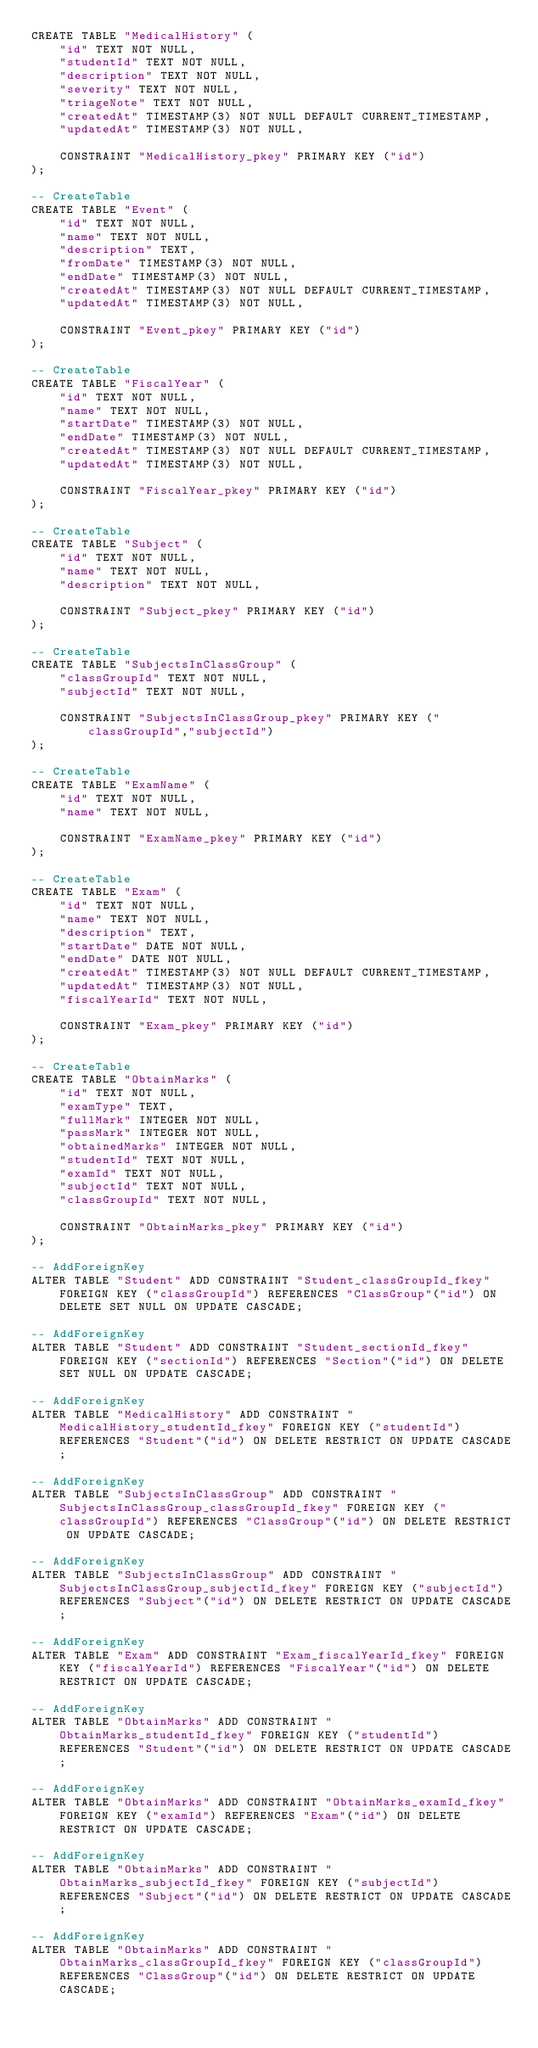Convert code to text. <code><loc_0><loc_0><loc_500><loc_500><_SQL_>CREATE TABLE "MedicalHistory" (
    "id" TEXT NOT NULL,
    "studentId" TEXT NOT NULL,
    "description" TEXT NOT NULL,
    "severity" TEXT NOT NULL,
    "triageNote" TEXT NOT NULL,
    "createdAt" TIMESTAMP(3) NOT NULL DEFAULT CURRENT_TIMESTAMP,
    "updatedAt" TIMESTAMP(3) NOT NULL,

    CONSTRAINT "MedicalHistory_pkey" PRIMARY KEY ("id")
);

-- CreateTable
CREATE TABLE "Event" (
    "id" TEXT NOT NULL,
    "name" TEXT NOT NULL,
    "description" TEXT,
    "fromDate" TIMESTAMP(3) NOT NULL,
    "endDate" TIMESTAMP(3) NOT NULL,
    "createdAt" TIMESTAMP(3) NOT NULL DEFAULT CURRENT_TIMESTAMP,
    "updatedAt" TIMESTAMP(3) NOT NULL,

    CONSTRAINT "Event_pkey" PRIMARY KEY ("id")
);

-- CreateTable
CREATE TABLE "FiscalYear" (
    "id" TEXT NOT NULL,
    "name" TEXT NOT NULL,
    "startDate" TIMESTAMP(3) NOT NULL,
    "endDate" TIMESTAMP(3) NOT NULL,
    "createdAt" TIMESTAMP(3) NOT NULL DEFAULT CURRENT_TIMESTAMP,
    "updatedAt" TIMESTAMP(3) NOT NULL,

    CONSTRAINT "FiscalYear_pkey" PRIMARY KEY ("id")
);

-- CreateTable
CREATE TABLE "Subject" (
    "id" TEXT NOT NULL,
    "name" TEXT NOT NULL,
    "description" TEXT NOT NULL,

    CONSTRAINT "Subject_pkey" PRIMARY KEY ("id")
);

-- CreateTable
CREATE TABLE "SubjectsInClassGroup" (
    "classGroupId" TEXT NOT NULL,
    "subjectId" TEXT NOT NULL,

    CONSTRAINT "SubjectsInClassGroup_pkey" PRIMARY KEY ("classGroupId","subjectId")
);

-- CreateTable
CREATE TABLE "ExamName" (
    "id" TEXT NOT NULL,
    "name" TEXT NOT NULL,

    CONSTRAINT "ExamName_pkey" PRIMARY KEY ("id")
);

-- CreateTable
CREATE TABLE "Exam" (
    "id" TEXT NOT NULL,
    "name" TEXT NOT NULL,
    "description" TEXT,
    "startDate" DATE NOT NULL,
    "endDate" DATE NOT NULL,
    "createdAt" TIMESTAMP(3) NOT NULL DEFAULT CURRENT_TIMESTAMP,
    "updatedAt" TIMESTAMP(3) NOT NULL,
    "fiscalYearId" TEXT NOT NULL,

    CONSTRAINT "Exam_pkey" PRIMARY KEY ("id")
);

-- CreateTable
CREATE TABLE "ObtainMarks" (
    "id" TEXT NOT NULL,
    "examType" TEXT,
    "fullMark" INTEGER NOT NULL,
    "passMark" INTEGER NOT NULL,
    "obtainedMarks" INTEGER NOT NULL,
    "studentId" TEXT NOT NULL,
    "examId" TEXT NOT NULL,
    "subjectId" TEXT NOT NULL,
    "classGroupId" TEXT NOT NULL,

    CONSTRAINT "ObtainMarks_pkey" PRIMARY KEY ("id")
);

-- AddForeignKey
ALTER TABLE "Student" ADD CONSTRAINT "Student_classGroupId_fkey" FOREIGN KEY ("classGroupId") REFERENCES "ClassGroup"("id") ON DELETE SET NULL ON UPDATE CASCADE;

-- AddForeignKey
ALTER TABLE "Student" ADD CONSTRAINT "Student_sectionId_fkey" FOREIGN KEY ("sectionId") REFERENCES "Section"("id") ON DELETE SET NULL ON UPDATE CASCADE;

-- AddForeignKey
ALTER TABLE "MedicalHistory" ADD CONSTRAINT "MedicalHistory_studentId_fkey" FOREIGN KEY ("studentId") REFERENCES "Student"("id") ON DELETE RESTRICT ON UPDATE CASCADE;

-- AddForeignKey
ALTER TABLE "SubjectsInClassGroup" ADD CONSTRAINT "SubjectsInClassGroup_classGroupId_fkey" FOREIGN KEY ("classGroupId") REFERENCES "ClassGroup"("id") ON DELETE RESTRICT ON UPDATE CASCADE;

-- AddForeignKey
ALTER TABLE "SubjectsInClassGroup" ADD CONSTRAINT "SubjectsInClassGroup_subjectId_fkey" FOREIGN KEY ("subjectId") REFERENCES "Subject"("id") ON DELETE RESTRICT ON UPDATE CASCADE;

-- AddForeignKey
ALTER TABLE "Exam" ADD CONSTRAINT "Exam_fiscalYearId_fkey" FOREIGN KEY ("fiscalYearId") REFERENCES "FiscalYear"("id") ON DELETE RESTRICT ON UPDATE CASCADE;

-- AddForeignKey
ALTER TABLE "ObtainMarks" ADD CONSTRAINT "ObtainMarks_studentId_fkey" FOREIGN KEY ("studentId") REFERENCES "Student"("id") ON DELETE RESTRICT ON UPDATE CASCADE;

-- AddForeignKey
ALTER TABLE "ObtainMarks" ADD CONSTRAINT "ObtainMarks_examId_fkey" FOREIGN KEY ("examId") REFERENCES "Exam"("id") ON DELETE RESTRICT ON UPDATE CASCADE;

-- AddForeignKey
ALTER TABLE "ObtainMarks" ADD CONSTRAINT "ObtainMarks_subjectId_fkey" FOREIGN KEY ("subjectId") REFERENCES "Subject"("id") ON DELETE RESTRICT ON UPDATE CASCADE;

-- AddForeignKey
ALTER TABLE "ObtainMarks" ADD CONSTRAINT "ObtainMarks_classGroupId_fkey" FOREIGN KEY ("classGroupId") REFERENCES "ClassGroup"("id") ON DELETE RESTRICT ON UPDATE CASCADE;
</code> 